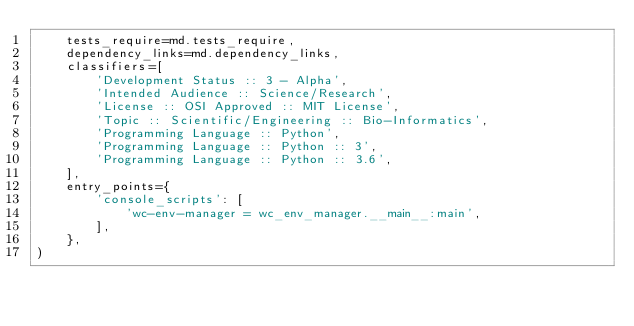Convert code to text. <code><loc_0><loc_0><loc_500><loc_500><_Python_>    tests_require=md.tests_require,
    dependency_links=md.dependency_links,
    classifiers=[
        'Development Status :: 3 - Alpha',
        'Intended Audience :: Science/Research',
        'License :: OSI Approved :: MIT License',
        'Topic :: Scientific/Engineering :: Bio-Informatics',
        'Programming Language :: Python',
        'Programming Language :: Python :: 3',
        'Programming Language :: Python :: 3.6',
    ],
    entry_points={
        'console_scripts': [
            'wc-env-manager = wc_env_manager.__main__:main',
        ],
    },
)
</code> 